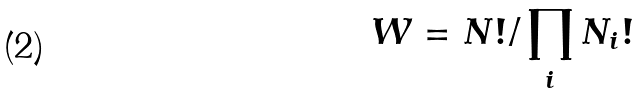<formula> <loc_0><loc_0><loc_500><loc_500>W = N ! / \prod _ { i } N _ { i } !</formula> 